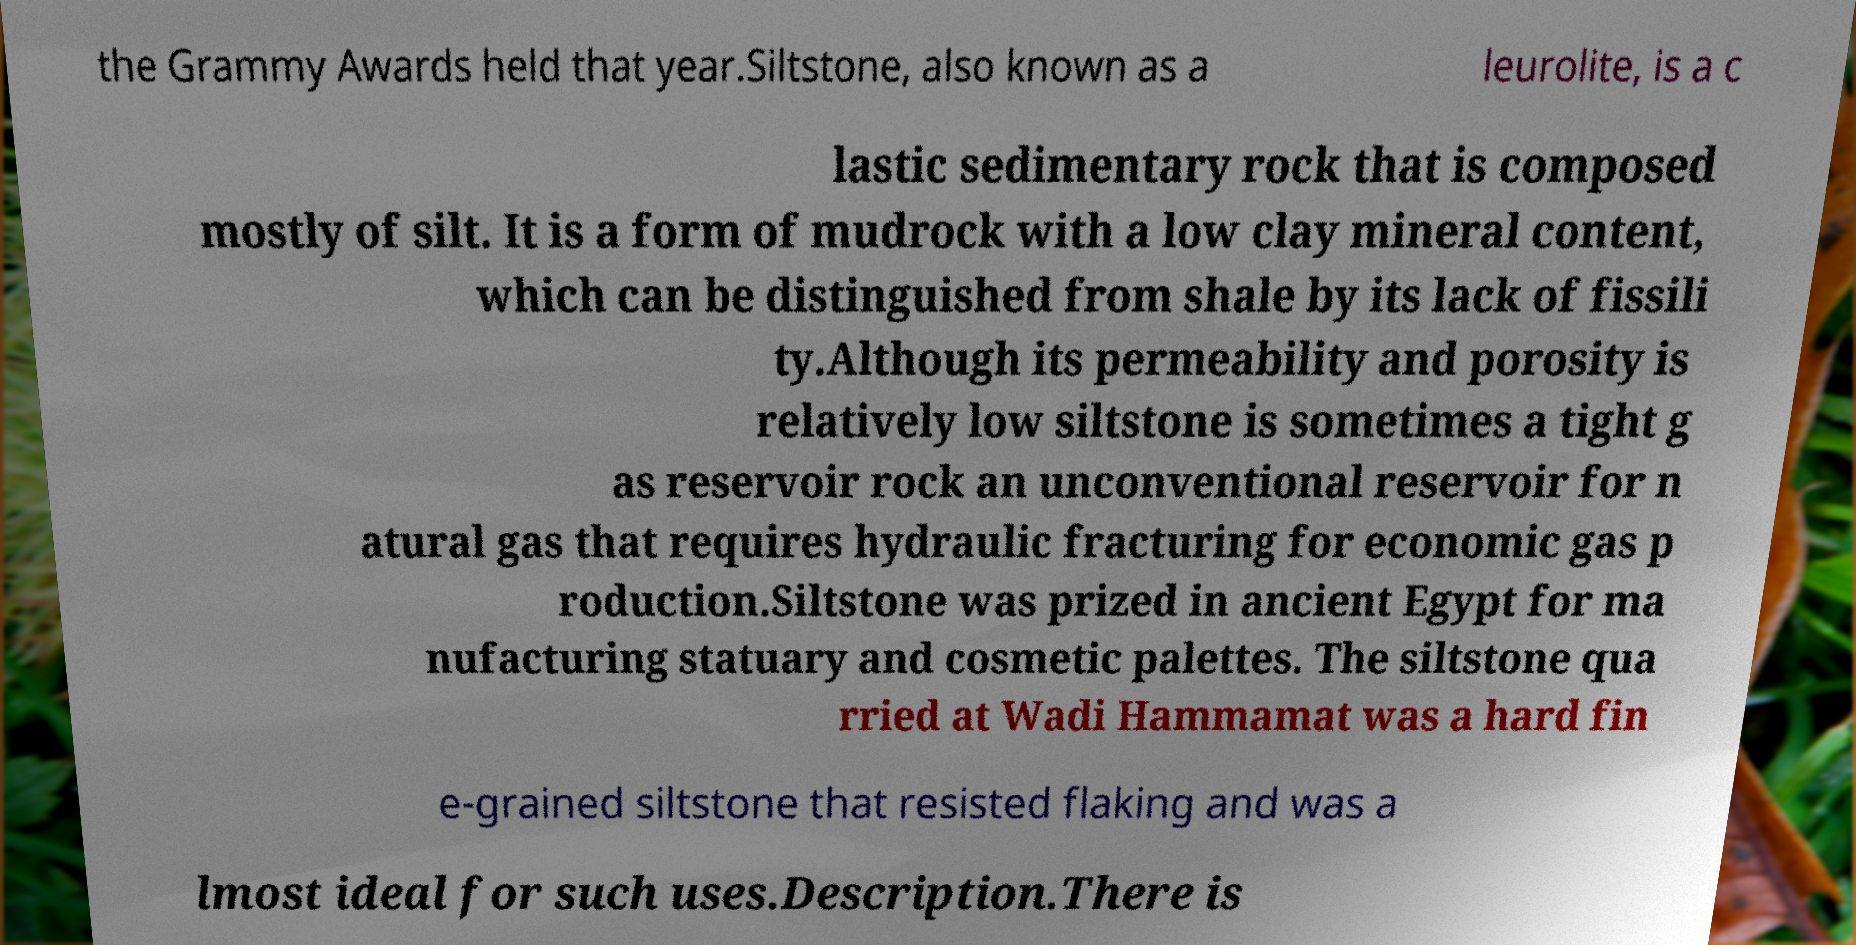Could you extract and type out the text from this image? the Grammy Awards held that year.Siltstone, also known as a leurolite, is a c lastic sedimentary rock that is composed mostly of silt. It is a form of mudrock with a low clay mineral content, which can be distinguished from shale by its lack of fissili ty.Although its permeability and porosity is relatively low siltstone is sometimes a tight g as reservoir rock an unconventional reservoir for n atural gas that requires hydraulic fracturing for economic gas p roduction.Siltstone was prized in ancient Egypt for ma nufacturing statuary and cosmetic palettes. The siltstone qua rried at Wadi Hammamat was a hard fin e-grained siltstone that resisted flaking and was a lmost ideal for such uses.Description.There is 